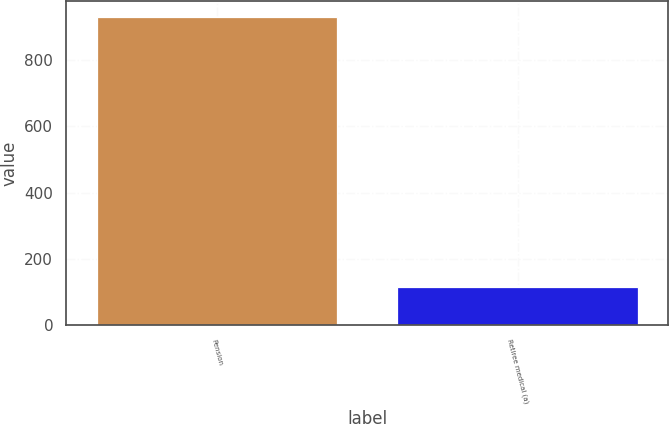Convert chart to OTSL. <chart><loc_0><loc_0><loc_500><loc_500><bar_chart><fcel>Pension<fcel>Retiree medical (a)<nl><fcel>930<fcel>115<nl></chart> 